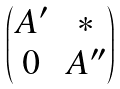Convert formula to latex. <formula><loc_0><loc_0><loc_500><loc_500>\begin{pmatrix} A ^ { \prime } & * \\ 0 & A ^ { \prime \prime } \end{pmatrix}</formula> 